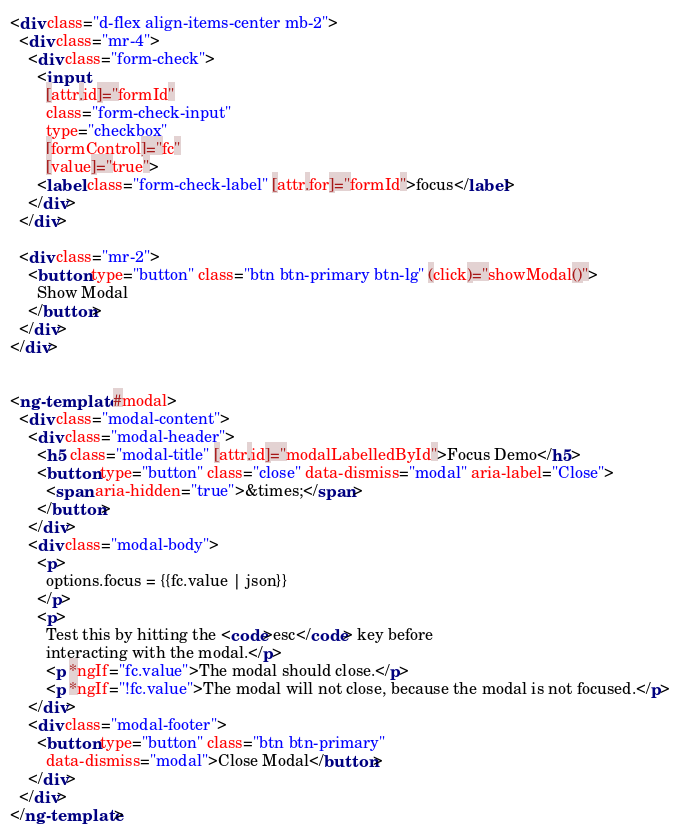<code> <loc_0><loc_0><loc_500><loc_500><_HTML_><div class="d-flex align-items-center mb-2">
  <div class="mr-4">
    <div class="form-check">
      <input
        [attr.id]="formId"
        class="form-check-input"
        type="checkbox"
        [formControl]="fc"
        [value]="true">
      <label class="form-check-label" [attr.for]="formId">focus</label>
    </div>
  </div>

  <div class="mr-2">
    <button type="button" class="btn btn-primary btn-lg" (click)="showModal()">
      Show Modal
    </button>
  </div>
</div>


<ng-template #modal>
  <div class="modal-content">
    <div class="modal-header">
      <h5 class="modal-title" [attr.id]="modalLabelledById">Focus Demo</h5>
      <button type="button" class="close" data-dismiss="modal" aria-label="Close">
        <span aria-hidden="true">&times;</span>
      </button>
    </div>
    <div class="modal-body">
      <p>
        options.focus = {{fc.value | json}}
      </p>
      <p>
        Test this by hitting the <code>esc</code> key before
        interacting with the modal.</p>
        <p *ngIf="fc.value">The modal should close.</p>
        <p *ngIf="!fc.value">The modal will not close, because the modal is not focused.</p>
    </div>
    <div class="modal-footer">
      <button type="button" class="btn btn-primary"
        data-dismiss="modal">Close Modal</button>
    </div>
  </div>
</ng-template>
</code> 